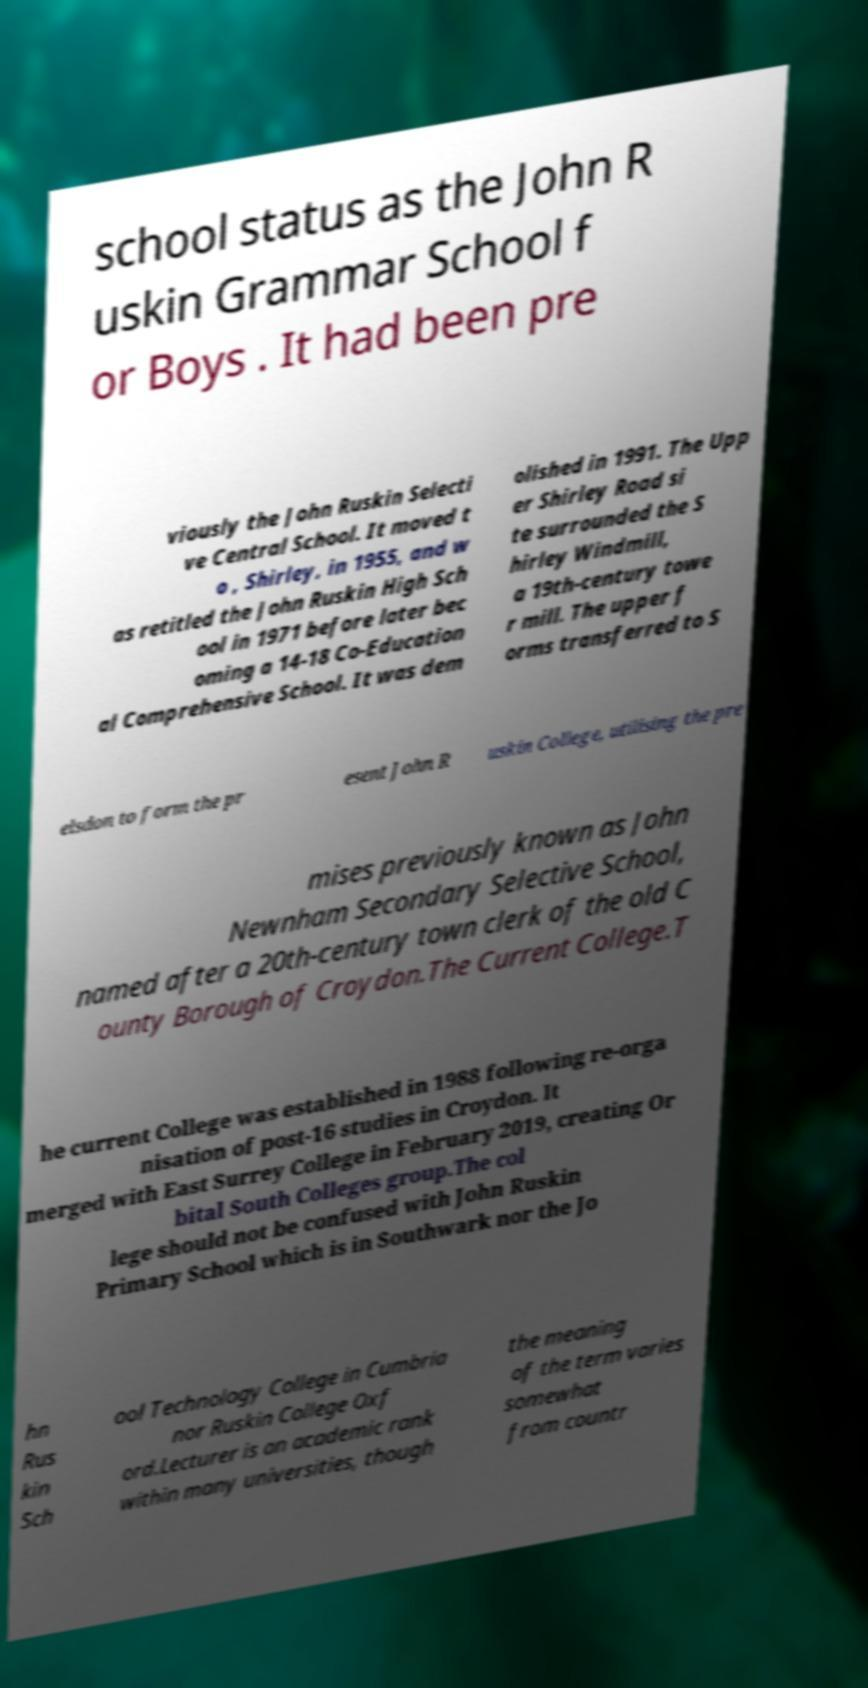Please read and relay the text visible in this image. What does it say? school status as the John R uskin Grammar School f or Boys . It had been pre viously the John Ruskin Selecti ve Central School. It moved t o , Shirley, in 1955, and w as retitled the John Ruskin High Sch ool in 1971 before later bec oming a 14-18 Co-Education al Comprehensive School. It was dem olished in 1991. The Upp er Shirley Road si te surrounded the S hirley Windmill, a 19th-century towe r mill. The upper f orms transferred to S elsdon to form the pr esent John R uskin College, utilising the pre mises previously known as John Newnham Secondary Selective School, named after a 20th-century town clerk of the old C ounty Borough of Croydon.The Current College.T he current College was established in 1988 following re-orga nisation of post-16 studies in Croydon. It merged with East Surrey College in February 2019, creating Or bital South Colleges group.The col lege should not be confused with John Ruskin Primary School which is in Southwark nor the Jo hn Rus kin Sch ool Technology College in Cumbria nor Ruskin College Oxf ord.Lecturer is an academic rank within many universities, though the meaning of the term varies somewhat from countr 